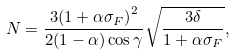Convert formula to latex. <formula><loc_0><loc_0><loc_500><loc_500>N = \frac { { 3 { { ( 1 + \alpha { \sigma _ { F } } ) } ^ { 2 } } } } { 2 ( 1 - \alpha ) \cos \gamma } \sqrt { \frac { 3 \delta } { { 1 + \alpha { \sigma _ { F } } } } } ,</formula> 